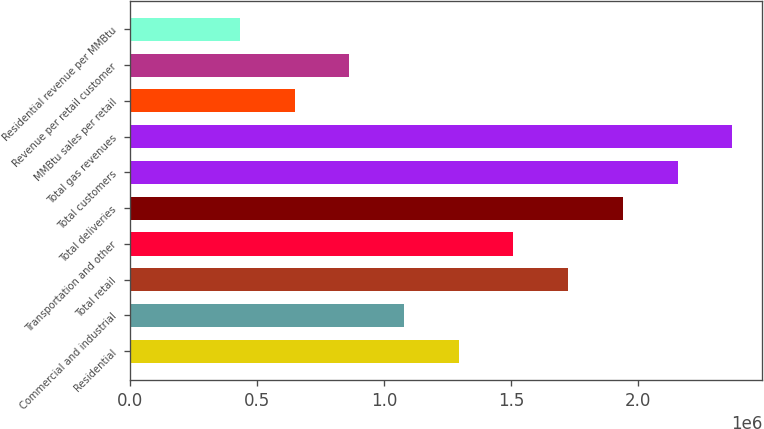Convert chart. <chart><loc_0><loc_0><loc_500><loc_500><bar_chart><fcel>Residential<fcel>Commercial and industrial<fcel>Total retail<fcel>Transportation and other<fcel>Total deliveries<fcel>Total customers<fcel>Total gas revenues<fcel>MMBtu sales per retail<fcel>Revenue per retail customer<fcel>Residential revenue per MMBtu<nl><fcel>1.2936e+06<fcel>1.078e+06<fcel>1.7248e+06<fcel>1.5092e+06<fcel>1.9404e+06<fcel>2.156e+06<fcel>2.3716e+06<fcel>646800<fcel>862400<fcel>431200<nl></chart> 